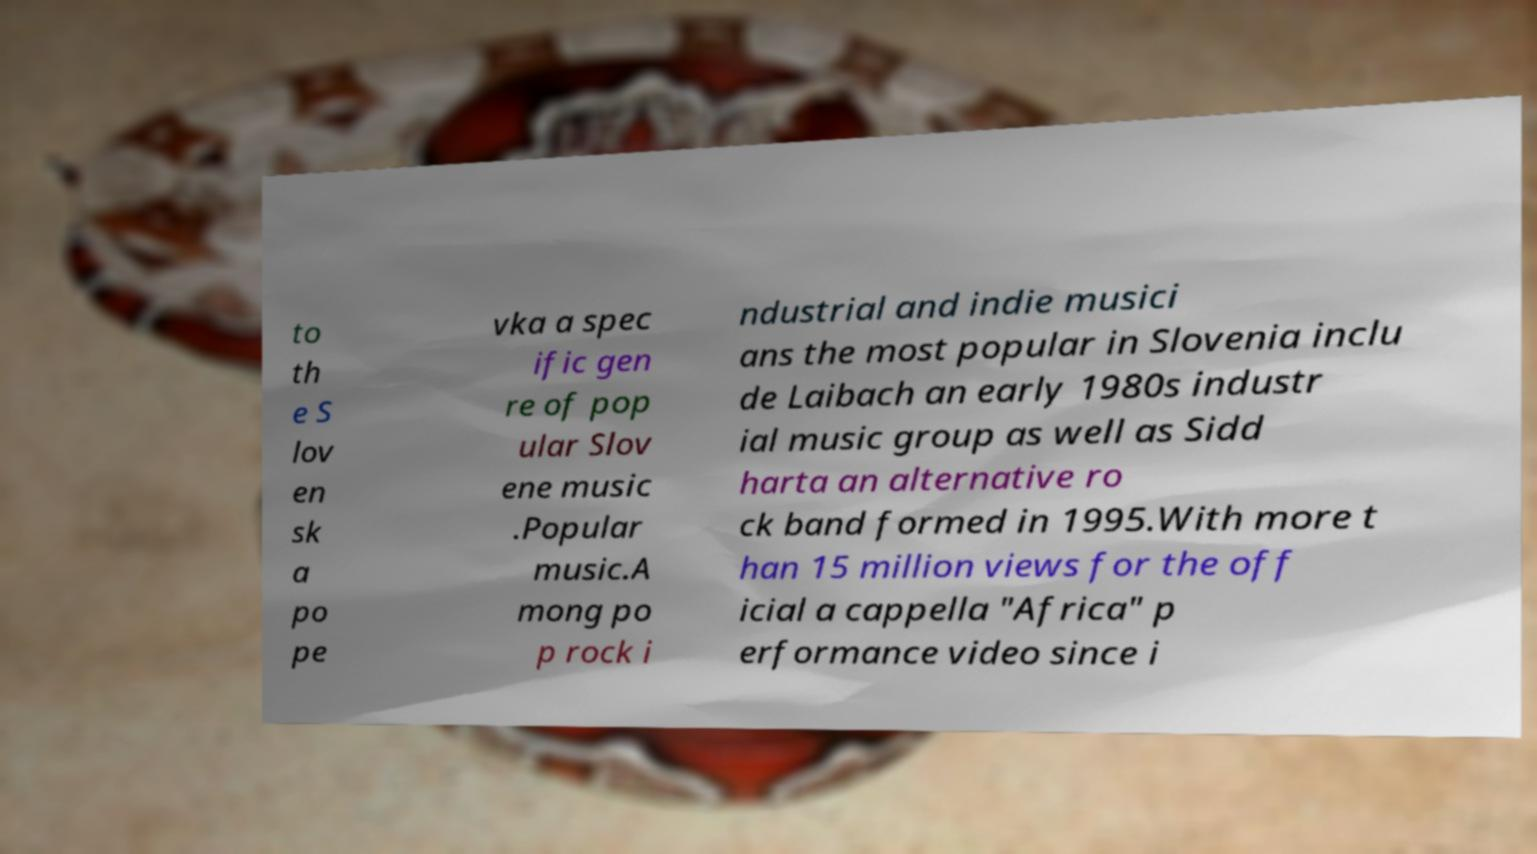Can you accurately transcribe the text from the provided image for me? to th e S lov en sk a po pe vka a spec ific gen re of pop ular Slov ene music .Popular music.A mong po p rock i ndustrial and indie musici ans the most popular in Slovenia inclu de Laibach an early 1980s industr ial music group as well as Sidd harta an alternative ro ck band formed in 1995.With more t han 15 million views for the off icial a cappella "Africa" p erformance video since i 